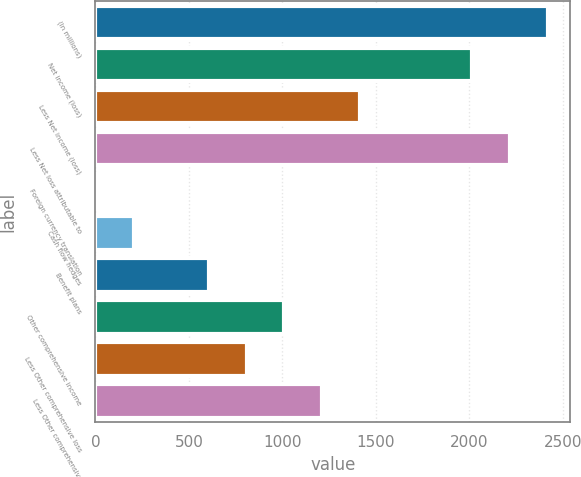<chart> <loc_0><loc_0><loc_500><loc_500><bar_chart><fcel>(In millions)<fcel>Net income (loss)<fcel>Less Net income (loss)<fcel>Less Net loss attributable to<fcel>Foreign currency translation<fcel>Cash flow hedges<fcel>Benefit plans<fcel>Other comprehensive income<fcel>Less Other comprehensive loss<fcel>Less Other comprehensive<nl><fcel>2419.8<fcel>2017<fcel>1412.8<fcel>2218.4<fcel>3<fcel>204.4<fcel>607.2<fcel>1010<fcel>808.6<fcel>1211.4<nl></chart> 